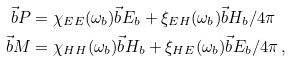<formula> <loc_0><loc_0><loc_500><loc_500>\vec { b } { P } & = \chi _ { E E } ( \omega _ { b } ) \vec { b } { E } _ { b } + \xi _ { E H } ( \omega _ { b } ) \vec { b } { H } _ { b } / 4 \pi \\ \vec { b } { M } & = \chi _ { H H } ( \omega _ { b } ) \vec { b } { H } _ { b } + \xi _ { H E } ( \omega _ { b } ) \vec { b } { E } _ { b } / 4 \pi \, ,</formula> 